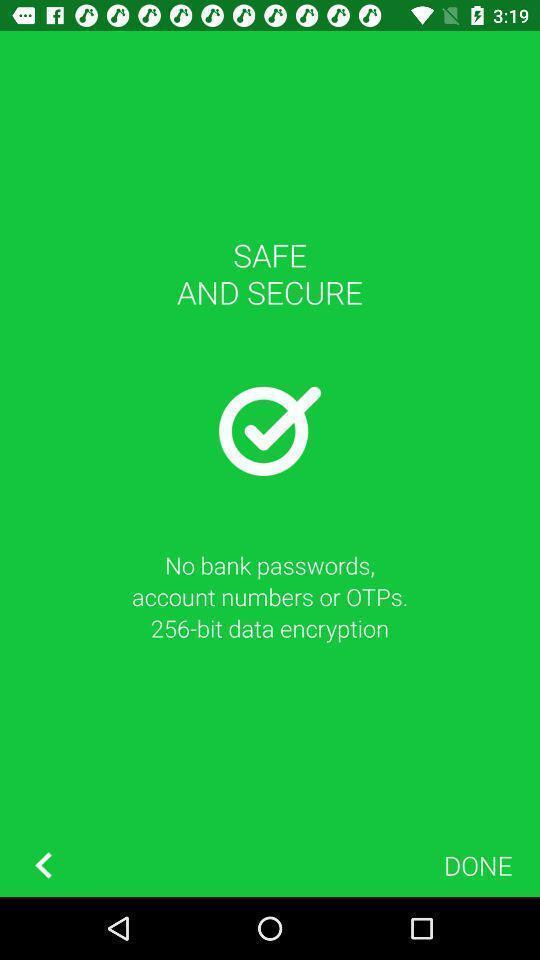Explain what's happening in this screen capture. Welcome page of daily expenditure tracker app. 